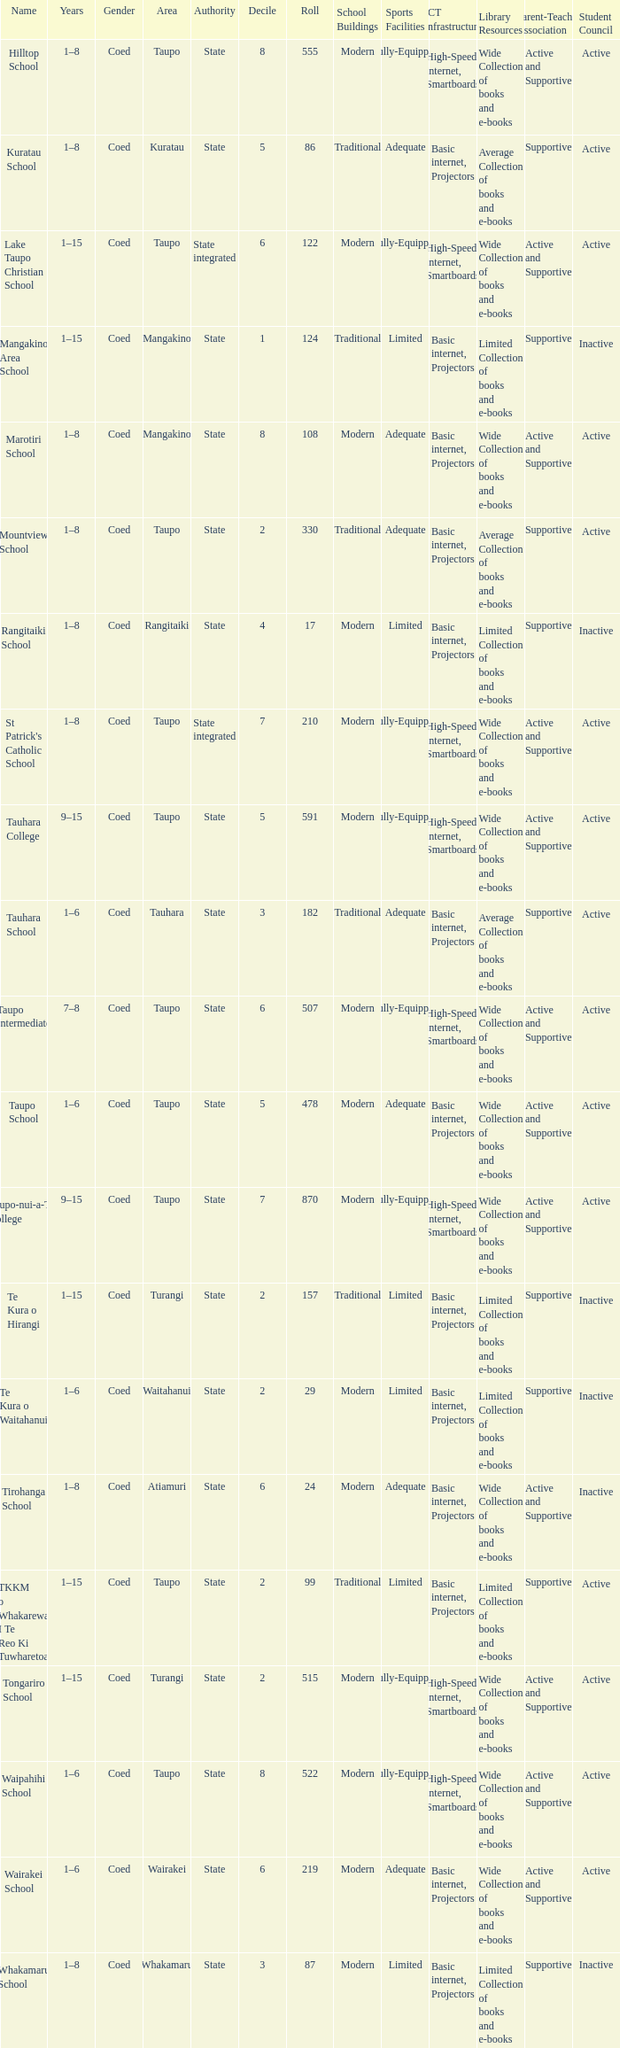What is the Whakamaru school's authority? State. 